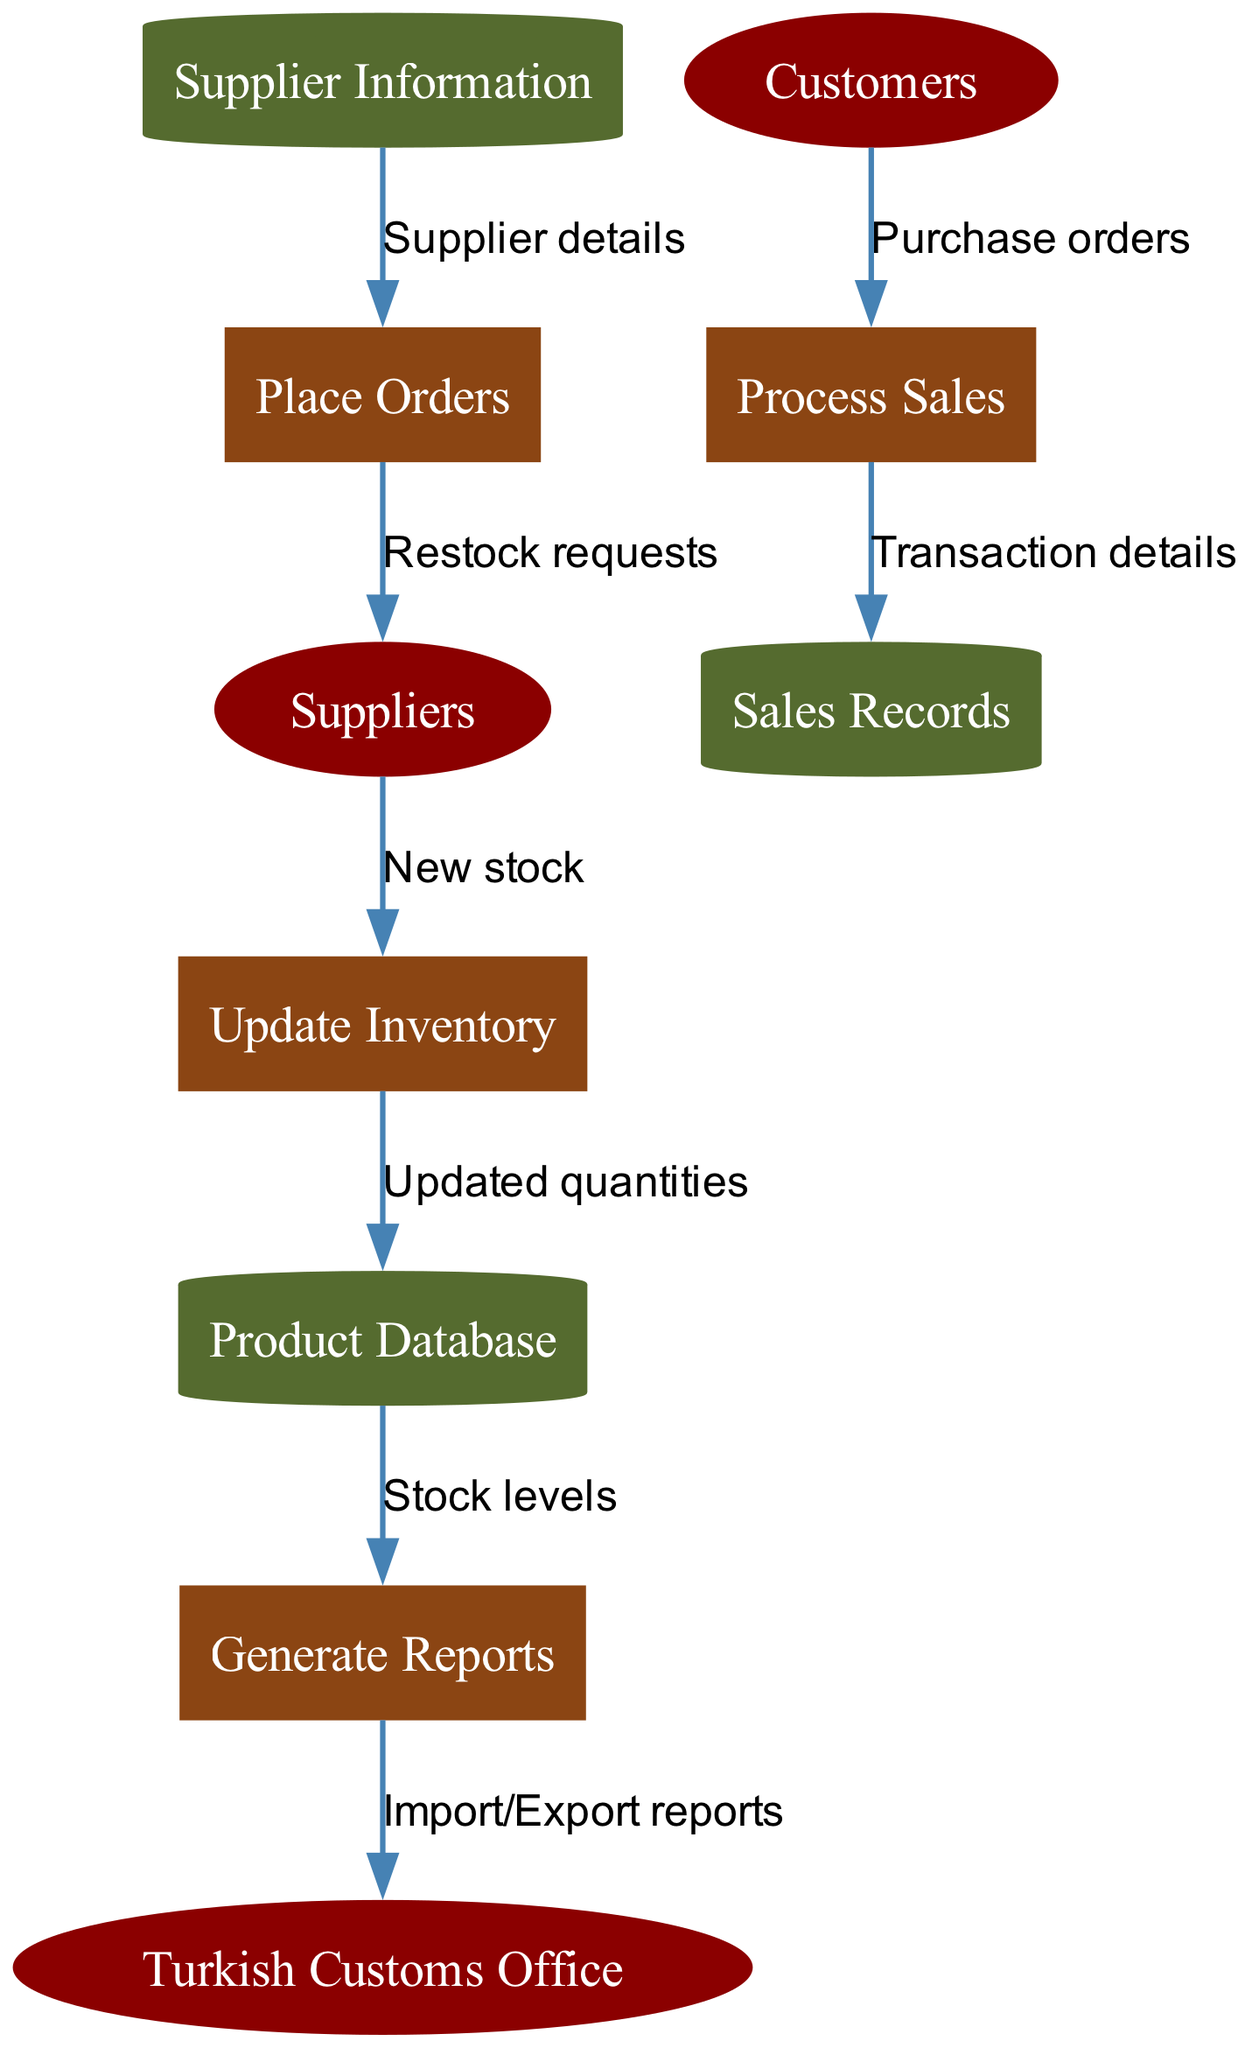What external entities are present in the diagram? The external entities listed in the diagram are "Suppliers," "Customers," and "Turkish Customs Office," as indicated by the shapes representing these entities.
Answer: Suppliers, Customers, Turkish Customs Office How many processes are in the diagram? By counting the processes listed, we identify "Update Inventory," "Process Sales," "Generate Reports," and "Place Orders," giving us a total of four processes in the diagram.
Answer: 4 What data flow goes from the Suppliers to the Update Inventory process? The data flow from Suppliers to the Update Inventory process is labeled "New stock," as depicted in the diagram connecting these two nodes.
Answer: New stock Which data store receives updated quantities? The "Product Database" is where the "Update Inventory" process sends the "Updated quantities," based on the flow represented in the diagram.
Answer: Product Database What report is generated to the Turkish Customs Office? The "Import/Export reports" flow identifies that the "Generate Reports" process sends this type of report to the Turkish Customs Office, as indicated in the diagram.
Answer: Import/Export reports How many data stores are displayed in the diagram? The diagram shows three data stores: "Product Database," "Sales Records," and "Supplier Information," accounting for a total of three data stores.
Answer: 3 What is needed to place orders? To place orders, "Supplier details" are required, which come from the "Supplier Information" data store as indicated in the flow direction from the data store to the Place Orders process.
Answer: Supplier details What type of flow connects the Process Sales to the Sales Records? The flow labeled "Transaction details" connects Process Sales to Sales Records, as shown in the diagram's data flow sections.
Answer: Transaction details What action is taken as a result of receiving new stock from Suppliers? As a result of receiving new stock from Suppliers, the "Update Inventory" process is executed, leading to the updating of quantities in the database.
Answer: Update Inventory 